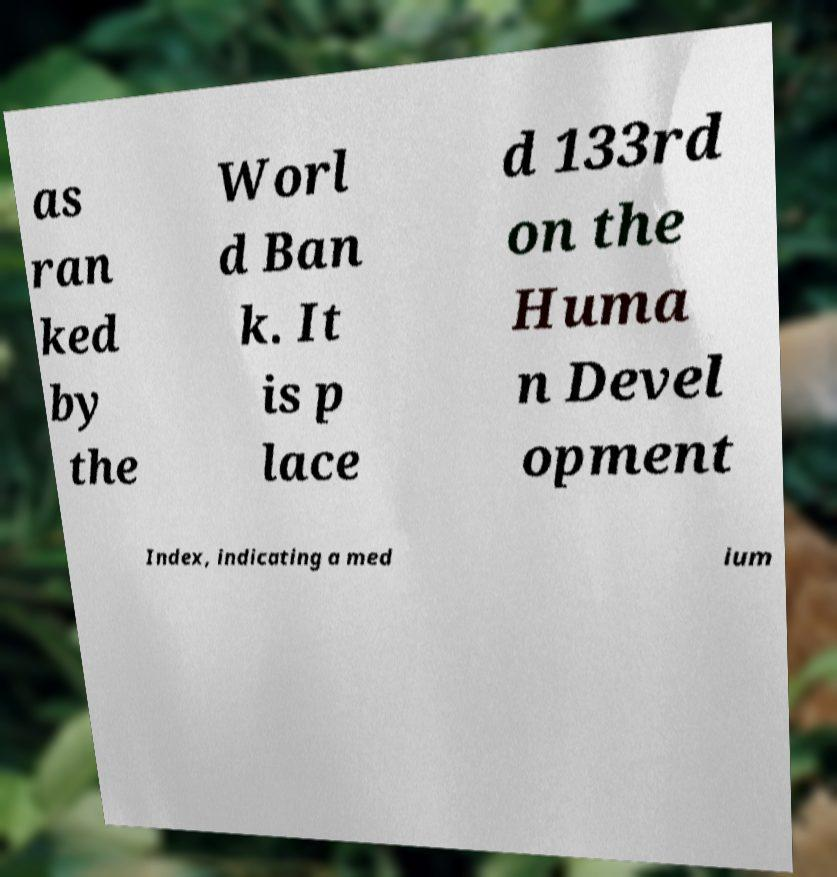Can you read and provide the text displayed in the image?This photo seems to have some interesting text. Can you extract and type it out for me? as ran ked by the Worl d Ban k. It is p lace d 133rd on the Huma n Devel opment Index, indicating a med ium 